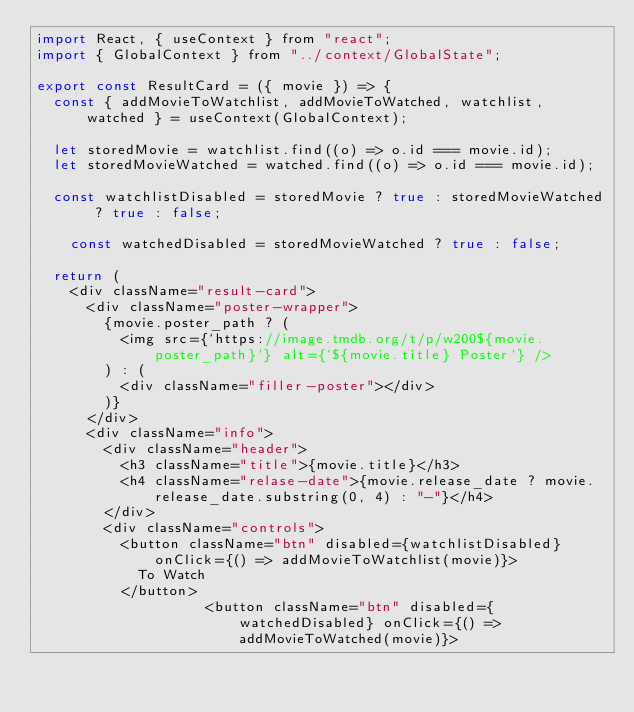Convert code to text. <code><loc_0><loc_0><loc_500><loc_500><_JavaScript_>import React, { useContext } from "react";
import { GlobalContext } from "../context/GlobalState";

export const ResultCard = ({ movie }) => {
	const { addMovieToWatchlist, addMovieToWatched, watchlist, watched } = useContext(GlobalContext);

	let storedMovie = watchlist.find((o) => o.id === movie.id);
	let storedMovieWatched = watched.find((o) => o.id === movie.id);

	const watchlistDisabled = storedMovie ? true : storedMovieWatched ? true : false;

    const watchedDisabled = storedMovieWatched ? true : false;

	return (
		<div className="result-card">
			<div className="poster-wrapper">
				{movie.poster_path ? (
					<img src={`https://image.tmdb.org/t/p/w200${movie.poster_path}`} alt={`${movie.title} Poster`} />
				) : (
					<div className="filler-poster"></div>
				)}
			</div>
			<div className="info">
				<div className="header">
					<h3 className="title">{movie.title}</h3>
					<h4 className="relase-date">{movie.release_date ? movie.release_date.substring(0, 4) : "-"}</h4>
				</div>
				<div className="controls">
					<button className="btn" disabled={watchlistDisabled} onClick={() => addMovieToWatchlist(movie)}>
						To Watch
					</button>
                    <button className="btn" disabled={watchedDisabled} onClick={() => addMovieToWatched(movie)}></code> 